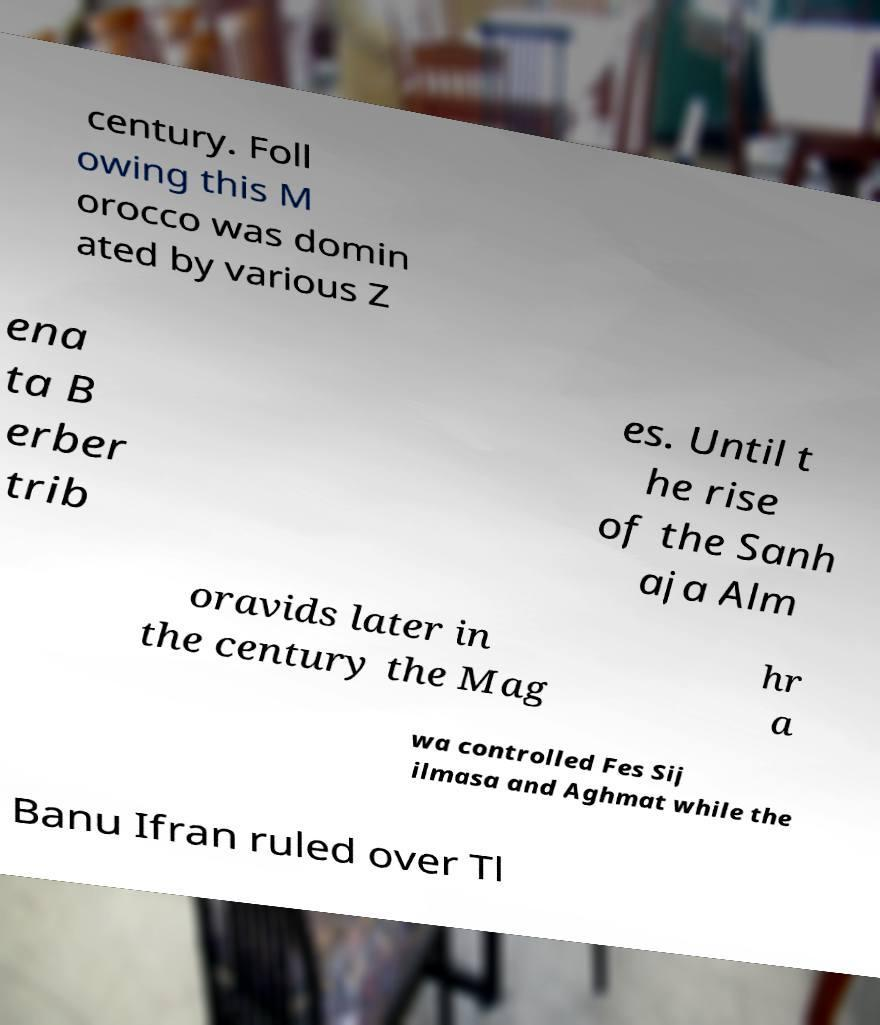Could you extract and type out the text from this image? century. Foll owing this M orocco was domin ated by various Z ena ta B erber trib es. Until t he rise of the Sanh aja Alm oravids later in the century the Mag hr a wa controlled Fes Sij ilmasa and Aghmat while the Banu Ifran ruled over Tl 